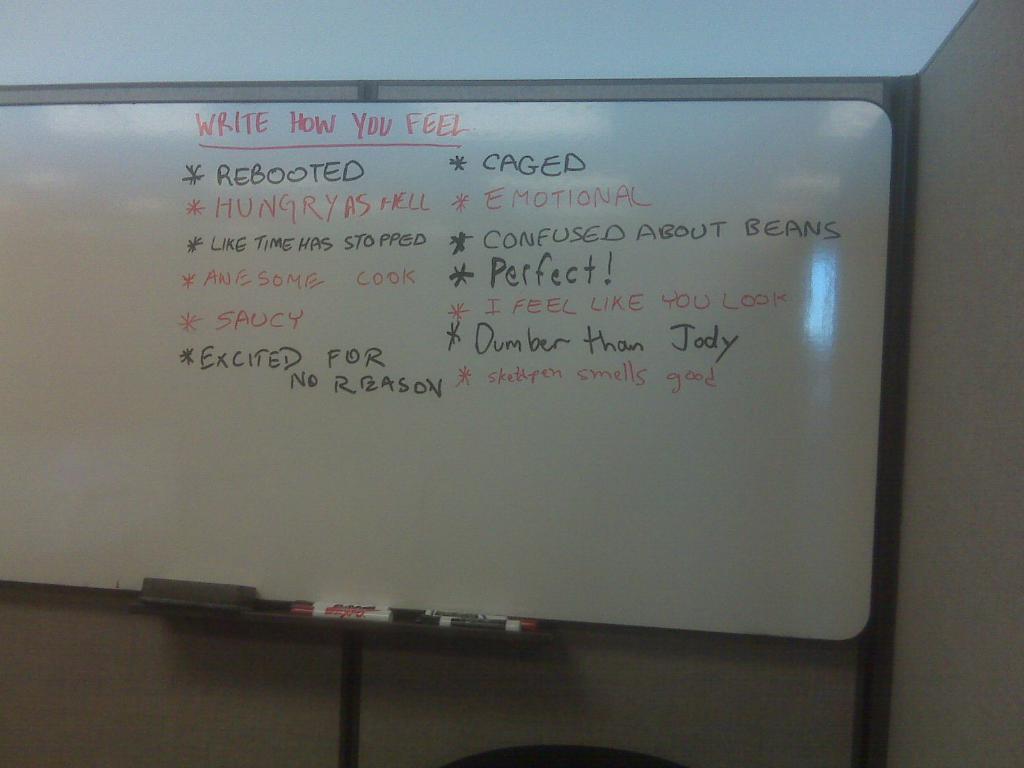Who does someone feel dumber than?
Provide a short and direct response. Jody. 